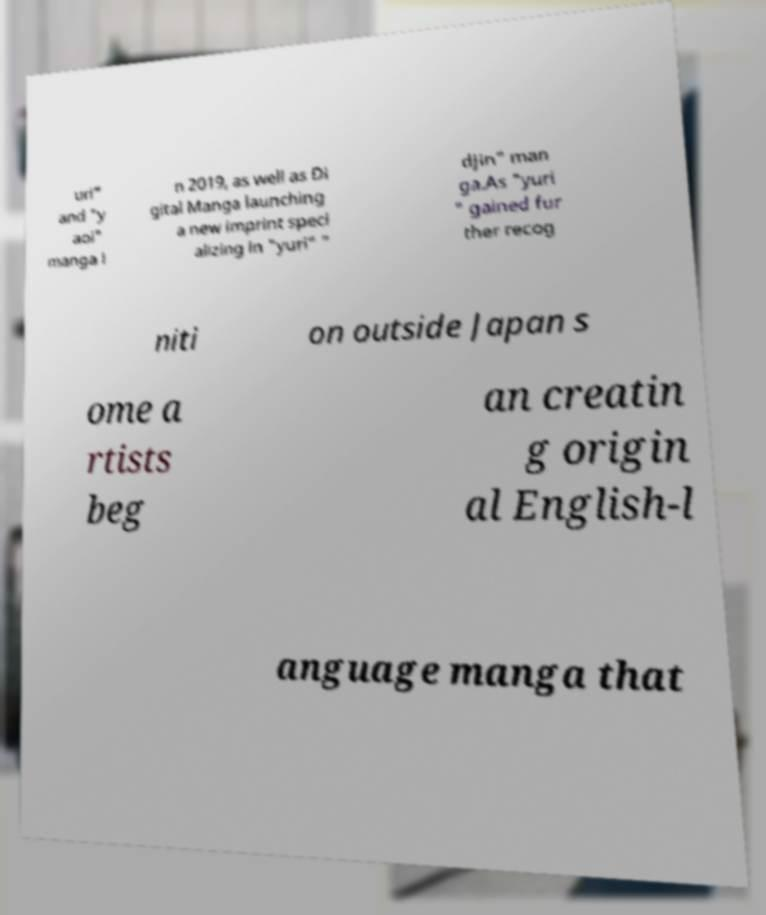There's text embedded in this image that I need extracted. Can you transcribe it verbatim? uri" and "y aoi" manga i n 2019, as well as Di gital Manga launching a new imprint speci alizing in "yuri" " djin" man ga.As "yuri " gained fur ther recog niti on outside Japan s ome a rtists beg an creatin g origin al English-l anguage manga that 